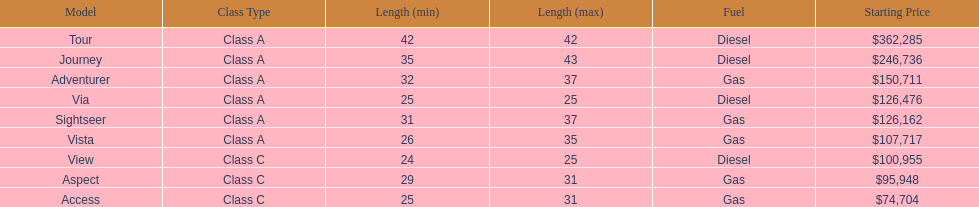What is the name of the top priced winnebago model? Tour. Parse the full table. {'header': ['Model', 'Class Type', 'Length (min)', 'Length (max)', 'Fuel', 'Starting Price'], 'rows': [['Tour', 'Class A', '42', '42', 'Diesel', '$362,285'], ['Journey', 'Class A', '35', '43', 'Diesel', '$246,736'], ['Adventurer', 'Class A', '32', '37', 'Gas', '$150,711'], ['Via', 'Class A', '25', '25', 'Diesel', '$126,476'], ['Sightseer', 'Class A', '31', '37', 'Gas', '$126,162'], ['Vista', 'Class A', '26', '35', 'Gas', '$107,717'], ['View', 'Class C', '24', '25', 'Diesel', '$100,955'], ['Aspect', 'Class C', '29', '31', 'Gas', '$95,948'], ['Access', 'Class C', '25', '31', 'Gas', '$74,704']]} 